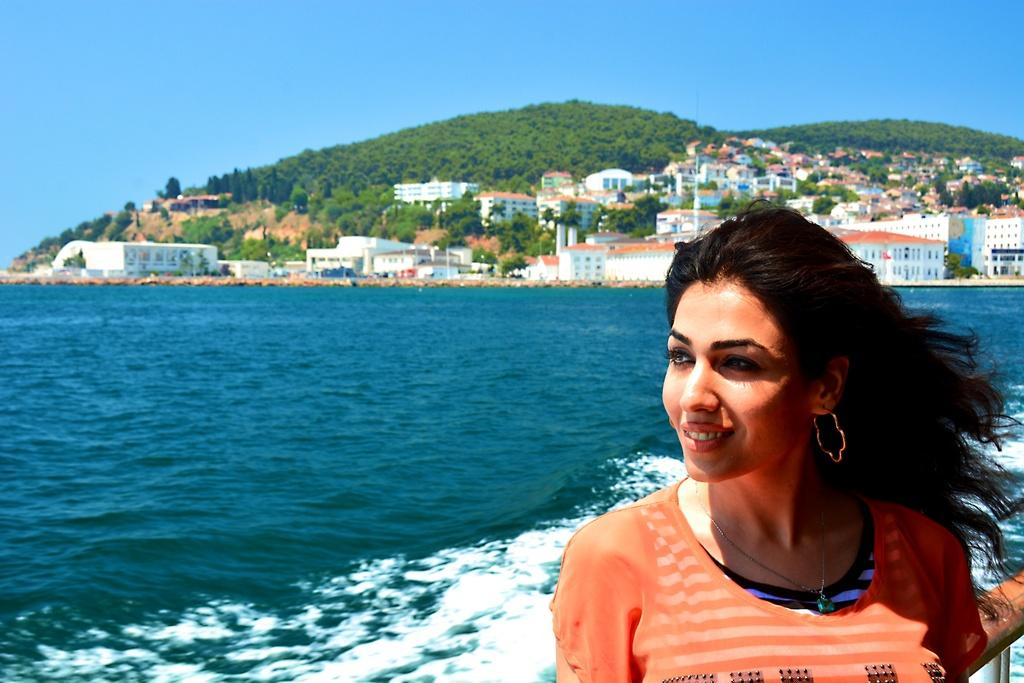What is the main subject of the image? There is a woman standing in the image. What can be seen in the background of the image? There is water, trees, and buildings visible in the image. What type of flag is being waved by the woman in the image? There is no flag visible in the image, and the woman is not waving anything. 